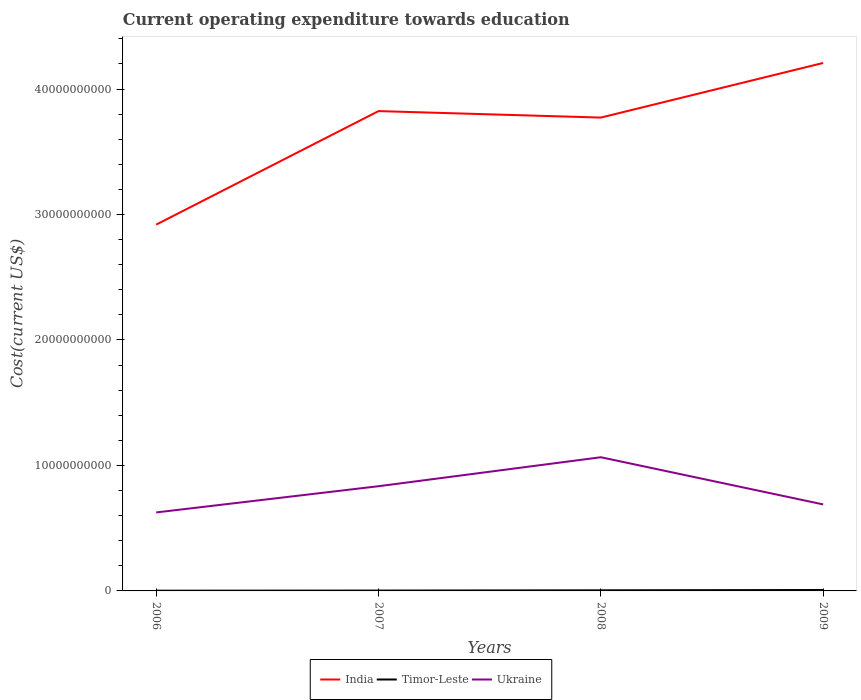Across all years, what is the maximum expenditure towards education in India?
Offer a terse response. 2.92e+1. What is the total expenditure towards education in Timor-Leste in the graph?
Offer a terse response. -2.46e+07. What is the difference between the highest and the second highest expenditure towards education in India?
Your answer should be compact. 1.29e+1. Is the expenditure towards education in Timor-Leste strictly greater than the expenditure towards education in India over the years?
Provide a short and direct response. Yes. How many years are there in the graph?
Keep it short and to the point. 4. What is the difference between two consecutive major ticks on the Y-axis?
Offer a very short reply. 1.00e+1. Are the values on the major ticks of Y-axis written in scientific E-notation?
Keep it short and to the point. No. Does the graph contain any zero values?
Offer a terse response. No. Where does the legend appear in the graph?
Provide a succinct answer. Bottom center. How many legend labels are there?
Your answer should be compact. 3. What is the title of the graph?
Your response must be concise. Current operating expenditure towards education. What is the label or title of the X-axis?
Provide a short and direct response. Years. What is the label or title of the Y-axis?
Provide a short and direct response. Cost(current US$). What is the Cost(current US$) of India in 2006?
Offer a very short reply. 2.92e+1. What is the Cost(current US$) of Timor-Leste in 2006?
Offer a terse response. 1.90e+07. What is the Cost(current US$) of Ukraine in 2006?
Your answer should be very brief. 6.26e+09. What is the Cost(current US$) of India in 2007?
Give a very brief answer. 3.82e+1. What is the Cost(current US$) of Timor-Leste in 2007?
Provide a short and direct response. 2.88e+07. What is the Cost(current US$) of Ukraine in 2007?
Ensure brevity in your answer.  8.35e+09. What is the Cost(current US$) of India in 2008?
Provide a succinct answer. 3.77e+1. What is the Cost(current US$) in Timor-Leste in 2008?
Give a very brief answer. 4.89e+07. What is the Cost(current US$) in Ukraine in 2008?
Offer a terse response. 1.07e+1. What is the Cost(current US$) in India in 2009?
Your answer should be very brief. 4.21e+1. What is the Cost(current US$) in Timor-Leste in 2009?
Keep it short and to the point. 7.35e+07. What is the Cost(current US$) in Ukraine in 2009?
Make the answer very short. 6.89e+09. Across all years, what is the maximum Cost(current US$) of India?
Offer a terse response. 4.21e+1. Across all years, what is the maximum Cost(current US$) of Timor-Leste?
Your answer should be very brief. 7.35e+07. Across all years, what is the maximum Cost(current US$) in Ukraine?
Provide a succinct answer. 1.07e+1. Across all years, what is the minimum Cost(current US$) in India?
Your response must be concise. 2.92e+1. Across all years, what is the minimum Cost(current US$) in Timor-Leste?
Your response must be concise. 1.90e+07. Across all years, what is the minimum Cost(current US$) of Ukraine?
Offer a very short reply. 6.26e+09. What is the total Cost(current US$) of India in the graph?
Your answer should be very brief. 1.47e+11. What is the total Cost(current US$) in Timor-Leste in the graph?
Provide a short and direct response. 1.70e+08. What is the total Cost(current US$) in Ukraine in the graph?
Keep it short and to the point. 3.21e+1. What is the difference between the Cost(current US$) in India in 2006 and that in 2007?
Your answer should be very brief. -9.05e+09. What is the difference between the Cost(current US$) in Timor-Leste in 2006 and that in 2007?
Provide a succinct answer. -9.78e+06. What is the difference between the Cost(current US$) of Ukraine in 2006 and that in 2007?
Keep it short and to the point. -2.09e+09. What is the difference between the Cost(current US$) of India in 2006 and that in 2008?
Your answer should be very brief. -8.53e+09. What is the difference between the Cost(current US$) in Timor-Leste in 2006 and that in 2008?
Keep it short and to the point. -2.98e+07. What is the difference between the Cost(current US$) of Ukraine in 2006 and that in 2008?
Keep it short and to the point. -4.40e+09. What is the difference between the Cost(current US$) of India in 2006 and that in 2009?
Provide a succinct answer. -1.29e+1. What is the difference between the Cost(current US$) in Timor-Leste in 2006 and that in 2009?
Give a very brief answer. -5.44e+07. What is the difference between the Cost(current US$) of Ukraine in 2006 and that in 2009?
Make the answer very short. -6.38e+08. What is the difference between the Cost(current US$) of India in 2007 and that in 2008?
Make the answer very short. 5.16e+08. What is the difference between the Cost(current US$) of Timor-Leste in 2007 and that in 2008?
Ensure brevity in your answer.  -2.00e+07. What is the difference between the Cost(current US$) of Ukraine in 2007 and that in 2008?
Make the answer very short. -2.31e+09. What is the difference between the Cost(current US$) of India in 2007 and that in 2009?
Give a very brief answer. -3.84e+09. What is the difference between the Cost(current US$) in Timor-Leste in 2007 and that in 2009?
Your answer should be compact. -4.46e+07. What is the difference between the Cost(current US$) in Ukraine in 2007 and that in 2009?
Offer a very short reply. 1.45e+09. What is the difference between the Cost(current US$) of India in 2008 and that in 2009?
Offer a terse response. -4.35e+09. What is the difference between the Cost(current US$) of Timor-Leste in 2008 and that in 2009?
Provide a succinct answer. -2.46e+07. What is the difference between the Cost(current US$) in Ukraine in 2008 and that in 2009?
Give a very brief answer. 3.76e+09. What is the difference between the Cost(current US$) of India in 2006 and the Cost(current US$) of Timor-Leste in 2007?
Provide a short and direct response. 2.92e+1. What is the difference between the Cost(current US$) in India in 2006 and the Cost(current US$) in Ukraine in 2007?
Your answer should be very brief. 2.08e+1. What is the difference between the Cost(current US$) of Timor-Leste in 2006 and the Cost(current US$) of Ukraine in 2007?
Your answer should be compact. -8.33e+09. What is the difference between the Cost(current US$) in India in 2006 and the Cost(current US$) in Timor-Leste in 2008?
Ensure brevity in your answer.  2.91e+1. What is the difference between the Cost(current US$) of India in 2006 and the Cost(current US$) of Ukraine in 2008?
Offer a terse response. 1.85e+1. What is the difference between the Cost(current US$) in Timor-Leste in 2006 and the Cost(current US$) in Ukraine in 2008?
Provide a succinct answer. -1.06e+1. What is the difference between the Cost(current US$) in India in 2006 and the Cost(current US$) in Timor-Leste in 2009?
Keep it short and to the point. 2.91e+1. What is the difference between the Cost(current US$) in India in 2006 and the Cost(current US$) in Ukraine in 2009?
Provide a succinct answer. 2.23e+1. What is the difference between the Cost(current US$) in Timor-Leste in 2006 and the Cost(current US$) in Ukraine in 2009?
Offer a terse response. -6.88e+09. What is the difference between the Cost(current US$) in India in 2007 and the Cost(current US$) in Timor-Leste in 2008?
Keep it short and to the point. 3.82e+1. What is the difference between the Cost(current US$) of India in 2007 and the Cost(current US$) of Ukraine in 2008?
Your answer should be compact. 2.76e+1. What is the difference between the Cost(current US$) of Timor-Leste in 2007 and the Cost(current US$) of Ukraine in 2008?
Your answer should be compact. -1.06e+1. What is the difference between the Cost(current US$) in India in 2007 and the Cost(current US$) in Timor-Leste in 2009?
Offer a very short reply. 3.82e+1. What is the difference between the Cost(current US$) of India in 2007 and the Cost(current US$) of Ukraine in 2009?
Give a very brief answer. 3.13e+1. What is the difference between the Cost(current US$) in Timor-Leste in 2007 and the Cost(current US$) in Ukraine in 2009?
Offer a very short reply. -6.87e+09. What is the difference between the Cost(current US$) of India in 2008 and the Cost(current US$) of Timor-Leste in 2009?
Ensure brevity in your answer.  3.77e+1. What is the difference between the Cost(current US$) of India in 2008 and the Cost(current US$) of Ukraine in 2009?
Provide a short and direct response. 3.08e+1. What is the difference between the Cost(current US$) of Timor-Leste in 2008 and the Cost(current US$) of Ukraine in 2009?
Give a very brief answer. -6.85e+09. What is the average Cost(current US$) in India per year?
Offer a very short reply. 3.68e+1. What is the average Cost(current US$) in Timor-Leste per year?
Keep it short and to the point. 4.25e+07. What is the average Cost(current US$) in Ukraine per year?
Provide a succinct answer. 8.04e+09. In the year 2006, what is the difference between the Cost(current US$) of India and Cost(current US$) of Timor-Leste?
Offer a terse response. 2.92e+1. In the year 2006, what is the difference between the Cost(current US$) in India and Cost(current US$) in Ukraine?
Your answer should be compact. 2.29e+1. In the year 2006, what is the difference between the Cost(current US$) in Timor-Leste and Cost(current US$) in Ukraine?
Make the answer very short. -6.24e+09. In the year 2007, what is the difference between the Cost(current US$) in India and Cost(current US$) in Timor-Leste?
Provide a short and direct response. 3.82e+1. In the year 2007, what is the difference between the Cost(current US$) in India and Cost(current US$) in Ukraine?
Make the answer very short. 2.99e+1. In the year 2007, what is the difference between the Cost(current US$) in Timor-Leste and Cost(current US$) in Ukraine?
Your answer should be very brief. -8.32e+09. In the year 2008, what is the difference between the Cost(current US$) of India and Cost(current US$) of Timor-Leste?
Make the answer very short. 3.77e+1. In the year 2008, what is the difference between the Cost(current US$) of India and Cost(current US$) of Ukraine?
Your answer should be very brief. 2.71e+1. In the year 2008, what is the difference between the Cost(current US$) in Timor-Leste and Cost(current US$) in Ukraine?
Offer a terse response. -1.06e+1. In the year 2009, what is the difference between the Cost(current US$) of India and Cost(current US$) of Timor-Leste?
Provide a succinct answer. 4.20e+1. In the year 2009, what is the difference between the Cost(current US$) of India and Cost(current US$) of Ukraine?
Keep it short and to the point. 3.52e+1. In the year 2009, what is the difference between the Cost(current US$) of Timor-Leste and Cost(current US$) of Ukraine?
Give a very brief answer. -6.82e+09. What is the ratio of the Cost(current US$) of India in 2006 to that in 2007?
Offer a very short reply. 0.76. What is the ratio of the Cost(current US$) of Timor-Leste in 2006 to that in 2007?
Provide a succinct answer. 0.66. What is the ratio of the Cost(current US$) in Ukraine in 2006 to that in 2007?
Offer a very short reply. 0.75. What is the ratio of the Cost(current US$) of India in 2006 to that in 2008?
Offer a terse response. 0.77. What is the ratio of the Cost(current US$) in Timor-Leste in 2006 to that in 2008?
Ensure brevity in your answer.  0.39. What is the ratio of the Cost(current US$) of Ukraine in 2006 to that in 2008?
Give a very brief answer. 0.59. What is the ratio of the Cost(current US$) in India in 2006 to that in 2009?
Give a very brief answer. 0.69. What is the ratio of the Cost(current US$) in Timor-Leste in 2006 to that in 2009?
Your answer should be very brief. 0.26. What is the ratio of the Cost(current US$) of Ukraine in 2006 to that in 2009?
Your response must be concise. 0.91. What is the ratio of the Cost(current US$) of India in 2007 to that in 2008?
Keep it short and to the point. 1.01. What is the ratio of the Cost(current US$) of Timor-Leste in 2007 to that in 2008?
Your answer should be very brief. 0.59. What is the ratio of the Cost(current US$) of Ukraine in 2007 to that in 2008?
Provide a short and direct response. 0.78. What is the ratio of the Cost(current US$) in India in 2007 to that in 2009?
Offer a very short reply. 0.91. What is the ratio of the Cost(current US$) in Timor-Leste in 2007 to that in 2009?
Make the answer very short. 0.39. What is the ratio of the Cost(current US$) in Ukraine in 2007 to that in 2009?
Make the answer very short. 1.21. What is the ratio of the Cost(current US$) in India in 2008 to that in 2009?
Your response must be concise. 0.9. What is the ratio of the Cost(current US$) in Timor-Leste in 2008 to that in 2009?
Make the answer very short. 0.67. What is the ratio of the Cost(current US$) in Ukraine in 2008 to that in 2009?
Your answer should be very brief. 1.55. What is the difference between the highest and the second highest Cost(current US$) of India?
Ensure brevity in your answer.  3.84e+09. What is the difference between the highest and the second highest Cost(current US$) of Timor-Leste?
Offer a very short reply. 2.46e+07. What is the difference between the highest and the second highest Cost(current US$) of Ukraine?
Ensure brevity in your answer.  2.31e+09. What is the difference between the highest and the lowest Cost(current US$) of India?
Provide a succinct answer. 1.29e+1. What is the difference between the highest and the lowest Cost(current US$) in Timor-Leste?
Offer a very short reply. 5.44e+07. What is the difference between the highest and the lowest Cost(current US$) of Ukraine?
Your response must be concise. 4.40e+09. 